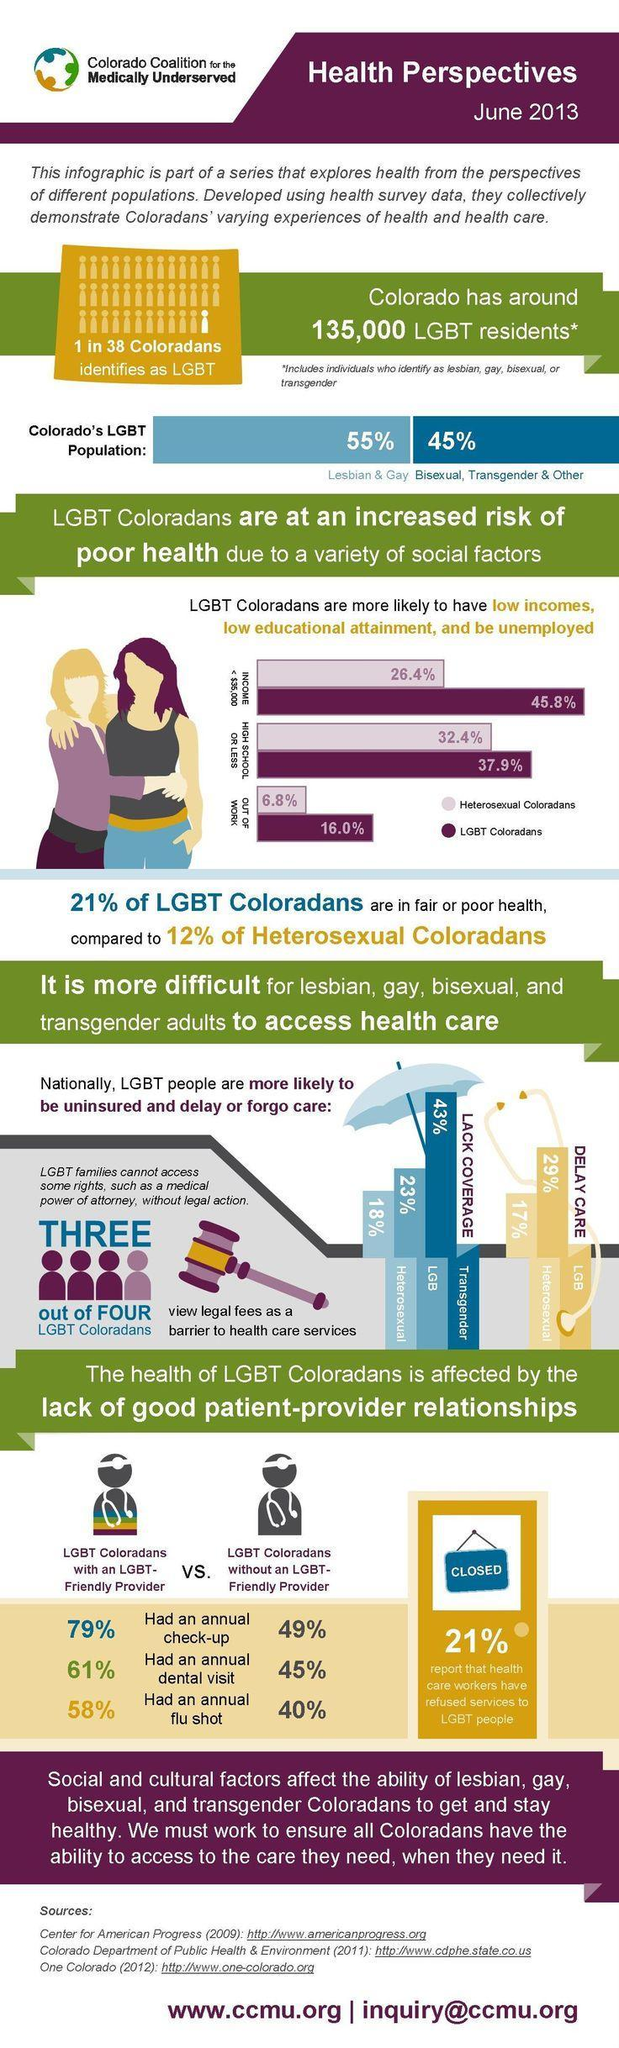What is the difference in LGBT Coloradan with and without a friendly provider had an annual check up?
Answer the question with a short phrase. 30% What is the total percentage LGBT Coloradana and Heterosexual Coloradans that are out of worK? 22.8% What is the increase in percentage of Lesbian & Gays population in comparison to the  Bisexual, Transgender & others in Colorado? 10% What was the increase in percentage of LGBT visiting a dentist when they had LGBT friendly provider? 16% Calculate the percentage of LGBT and Transgender that lack coverage and delay care? 95% What is the percentage difference between LGBT and Heterosexuals in Colorado? 9% What was the increase in percentage of LGBT taking a flu shot when they had LGBT friendly provider? 18% 